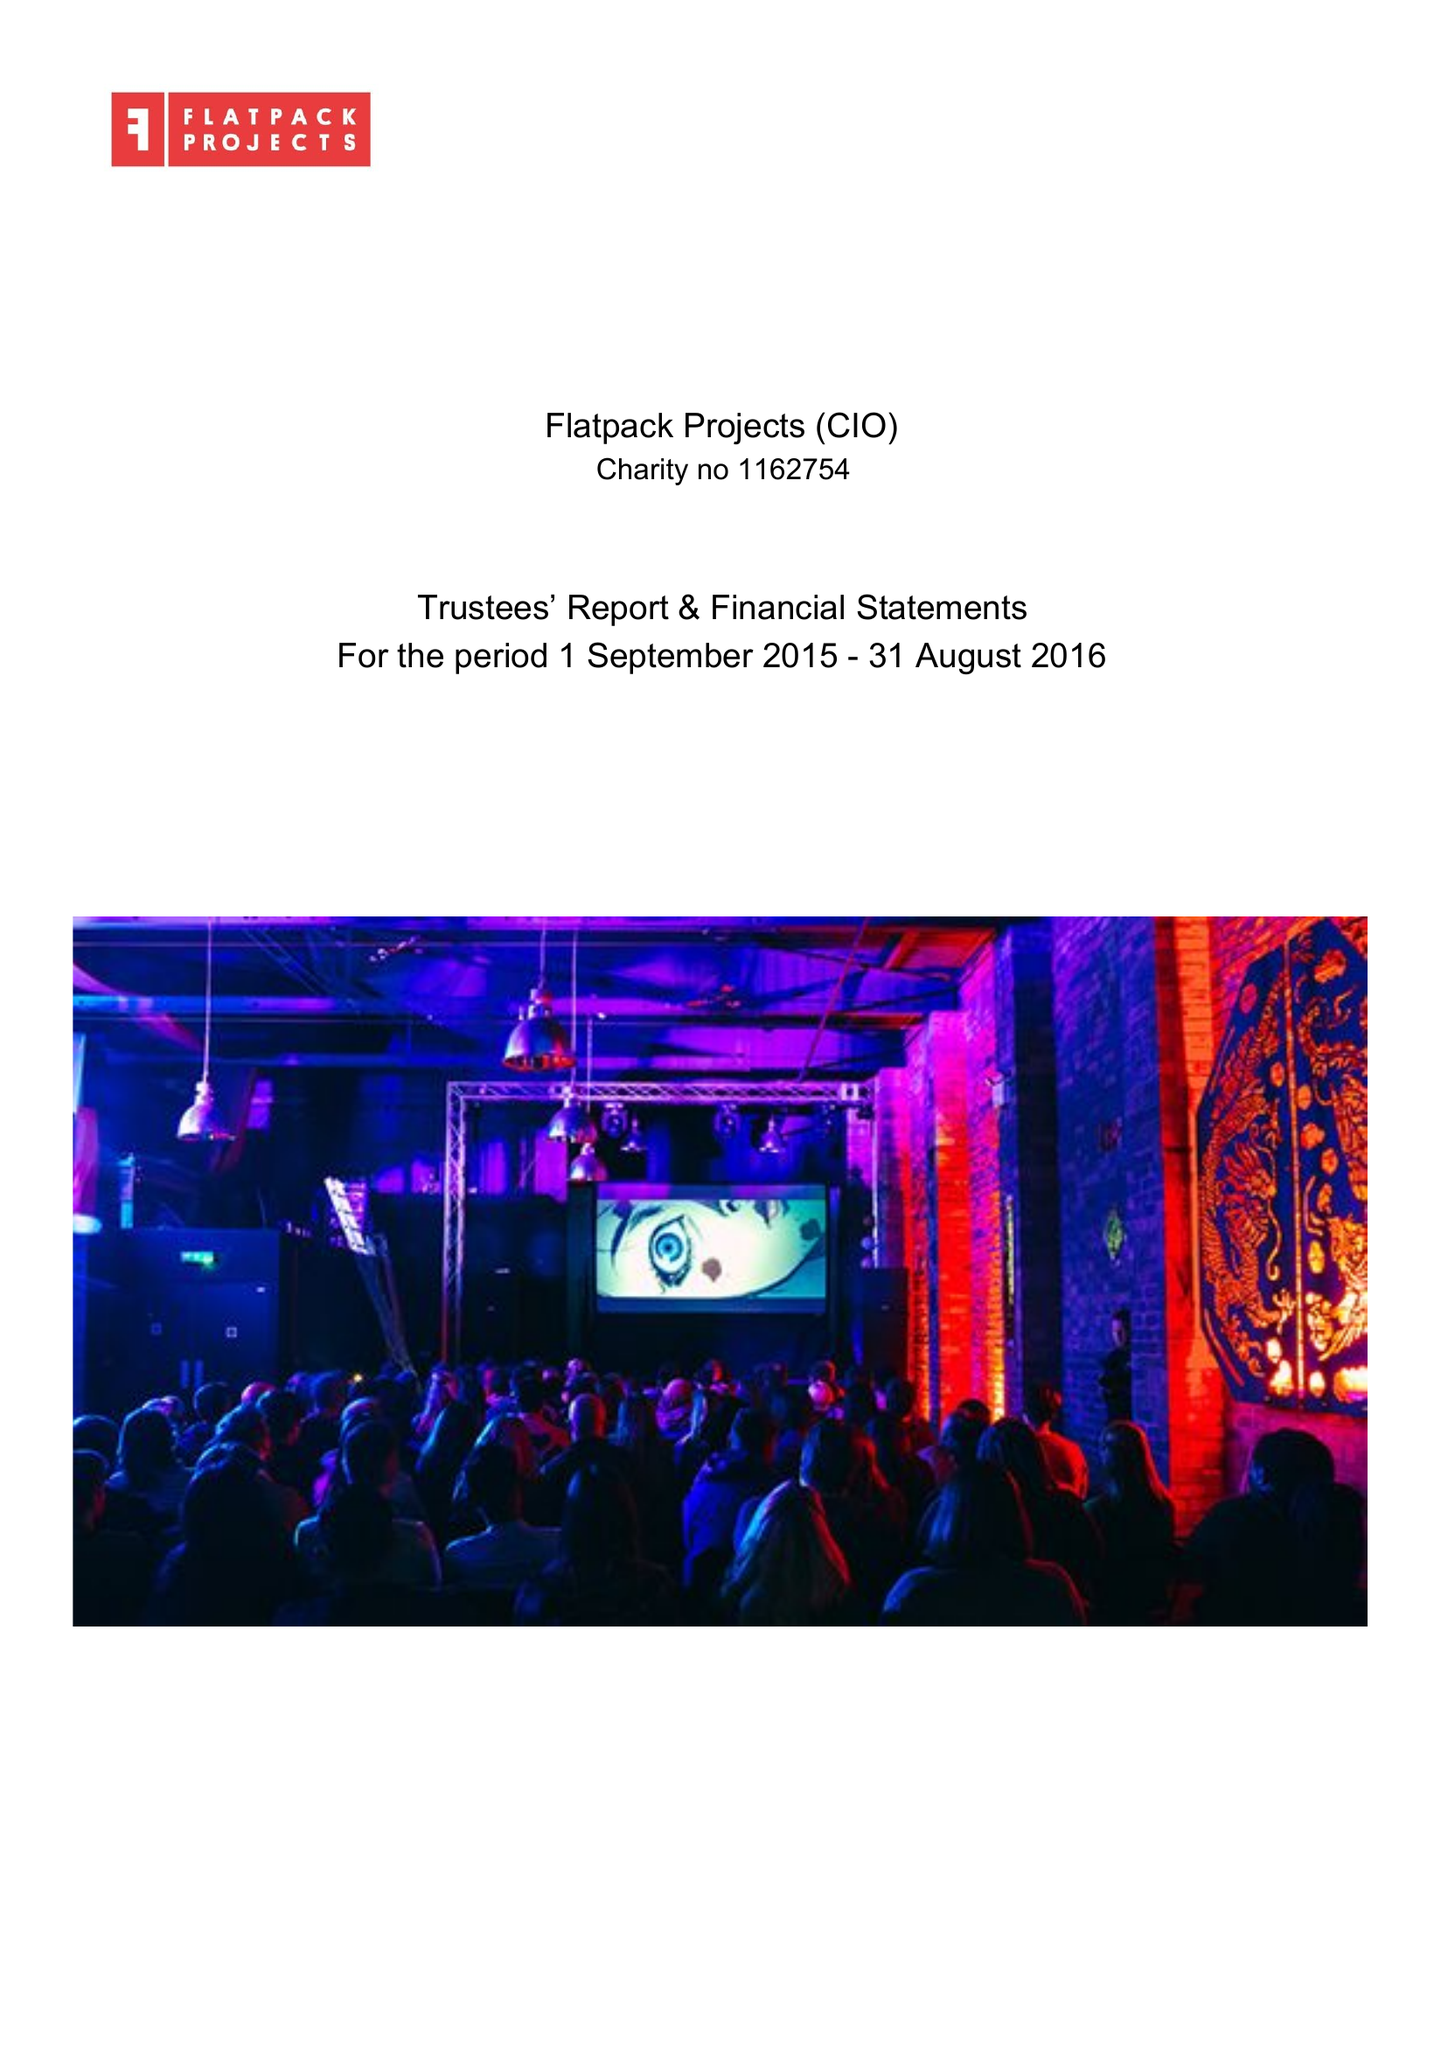What is the value for the spending_annually_in_british_pounds?
Answer the question using a single word or phrase. 299212.00 